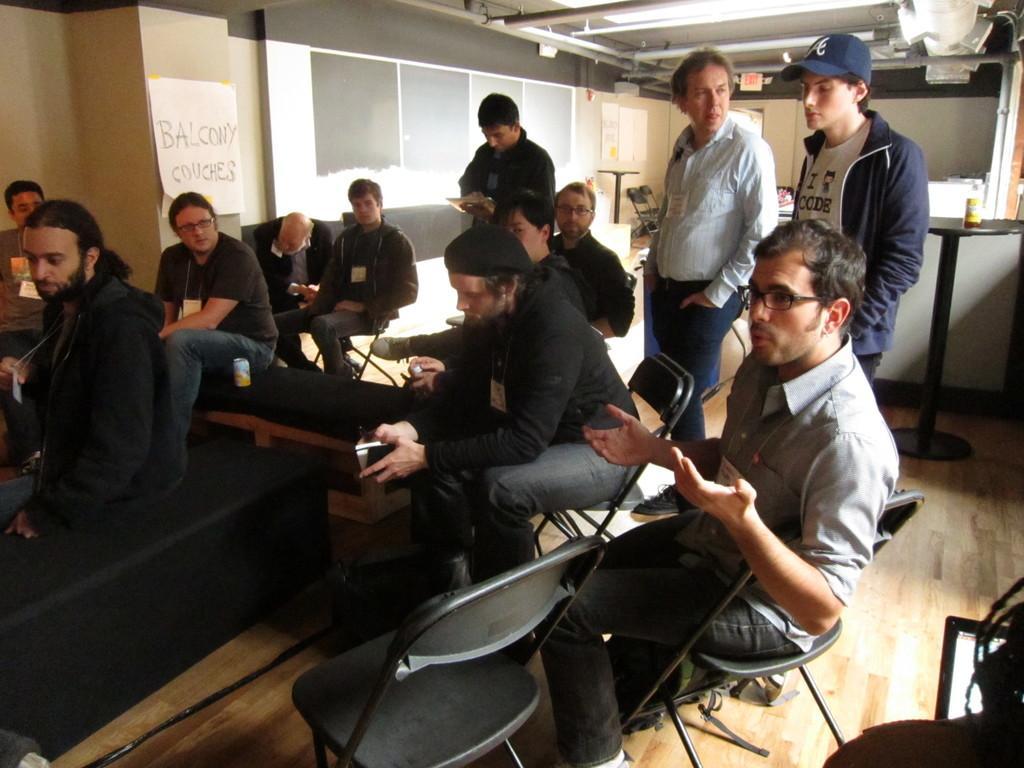Please provide a concise description of this image. In this picture there are group of people who are sitting on the chair. There is a paper on the wall. There are three men who are standing at the background. There is a bottle on the table. 